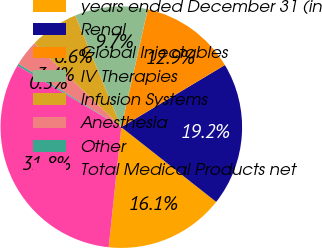<chart> <loc_0><loc_0><loc_500><loc_500><pie_chart><fcel>years ended December 31 (in<fcel>Renal<fcel>Global Injectables<fcel>IV Therapies<fcel>Infusion Systems<fcel>Anesthesia<fcel>Other<fcel>Total Medical Products net<nl><fcel>16.05%<fcel>19.21%<fcel>12.89%<fcel>9.74%<fcel>6.58%<fcel>3.42%<fcel>0.27%<fcel>31.83%<nl></chart> 